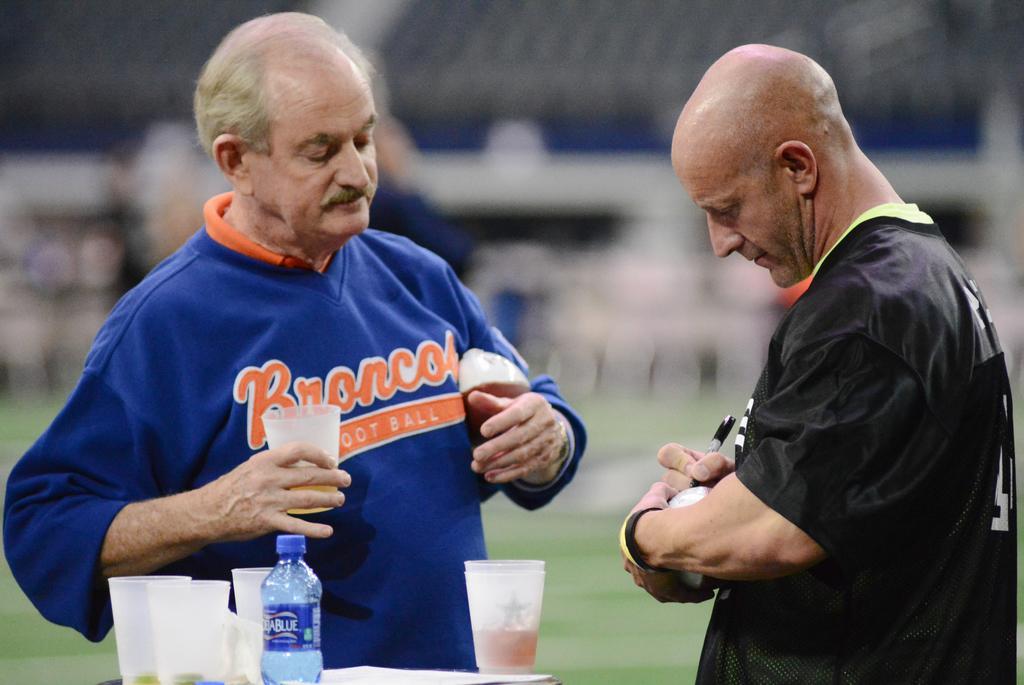Describe this image in one or two sentences. In the image we can see there are two men who are standing and in front of them there is table on which there are glasses and a water bottle. 